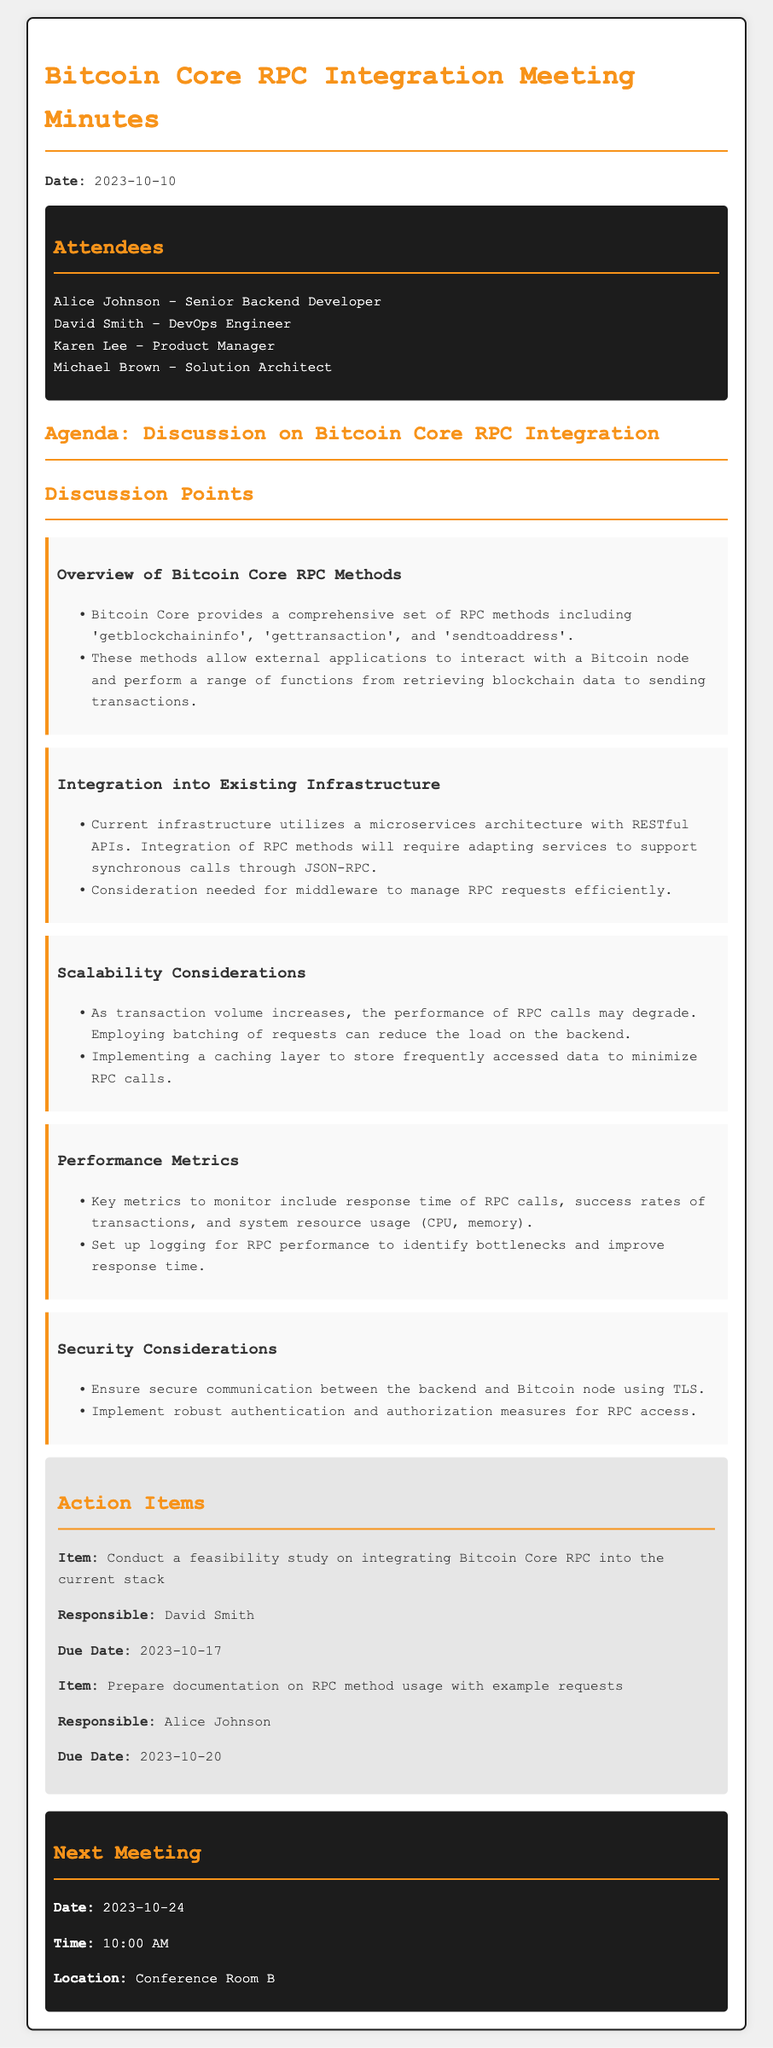What is the date of the meeting? The date of the meeting is specified in the document, which is 2023-10-10.
Answer: 2023-10-10 Who is responsible for the documentation on RPC method usage? The document lists action items and assigns responsibilities, indicating that Alice Johnson is responsible.
Answer: Alice Johnson What is one of the key metrics to monitor as mentioned in the performance metrics? The document specifies that monitoring the response time of RPC calls is essential.
Answer: response time of RPC calls What is the due date for the feasibility study on integrating Bitcoin Core RPC? The action item specifies that the due date for the study is 2023-10-17.
Answer: 2023-10-17 What security measure is suggested for communication between the backend and Bitcoin node? The discussion point mentions using TLS for secure communication.
Answer: TLS What is the next meeting date? The document explicitly states that the next meeting is scheduled for 2023-10-24.
Answer: 2023-10-24 What architecture does the current infrastructure utilize? The document specifies that the current infrastructure uses a microservices architecture with RESTful APIs.
Answer: microservices architecture Which RPC method retrieves information about the blockchain? The document lists 'getblockchaininfo' as an RPC method for retrieving blockchain information.
Answer: getblockchaininfo 